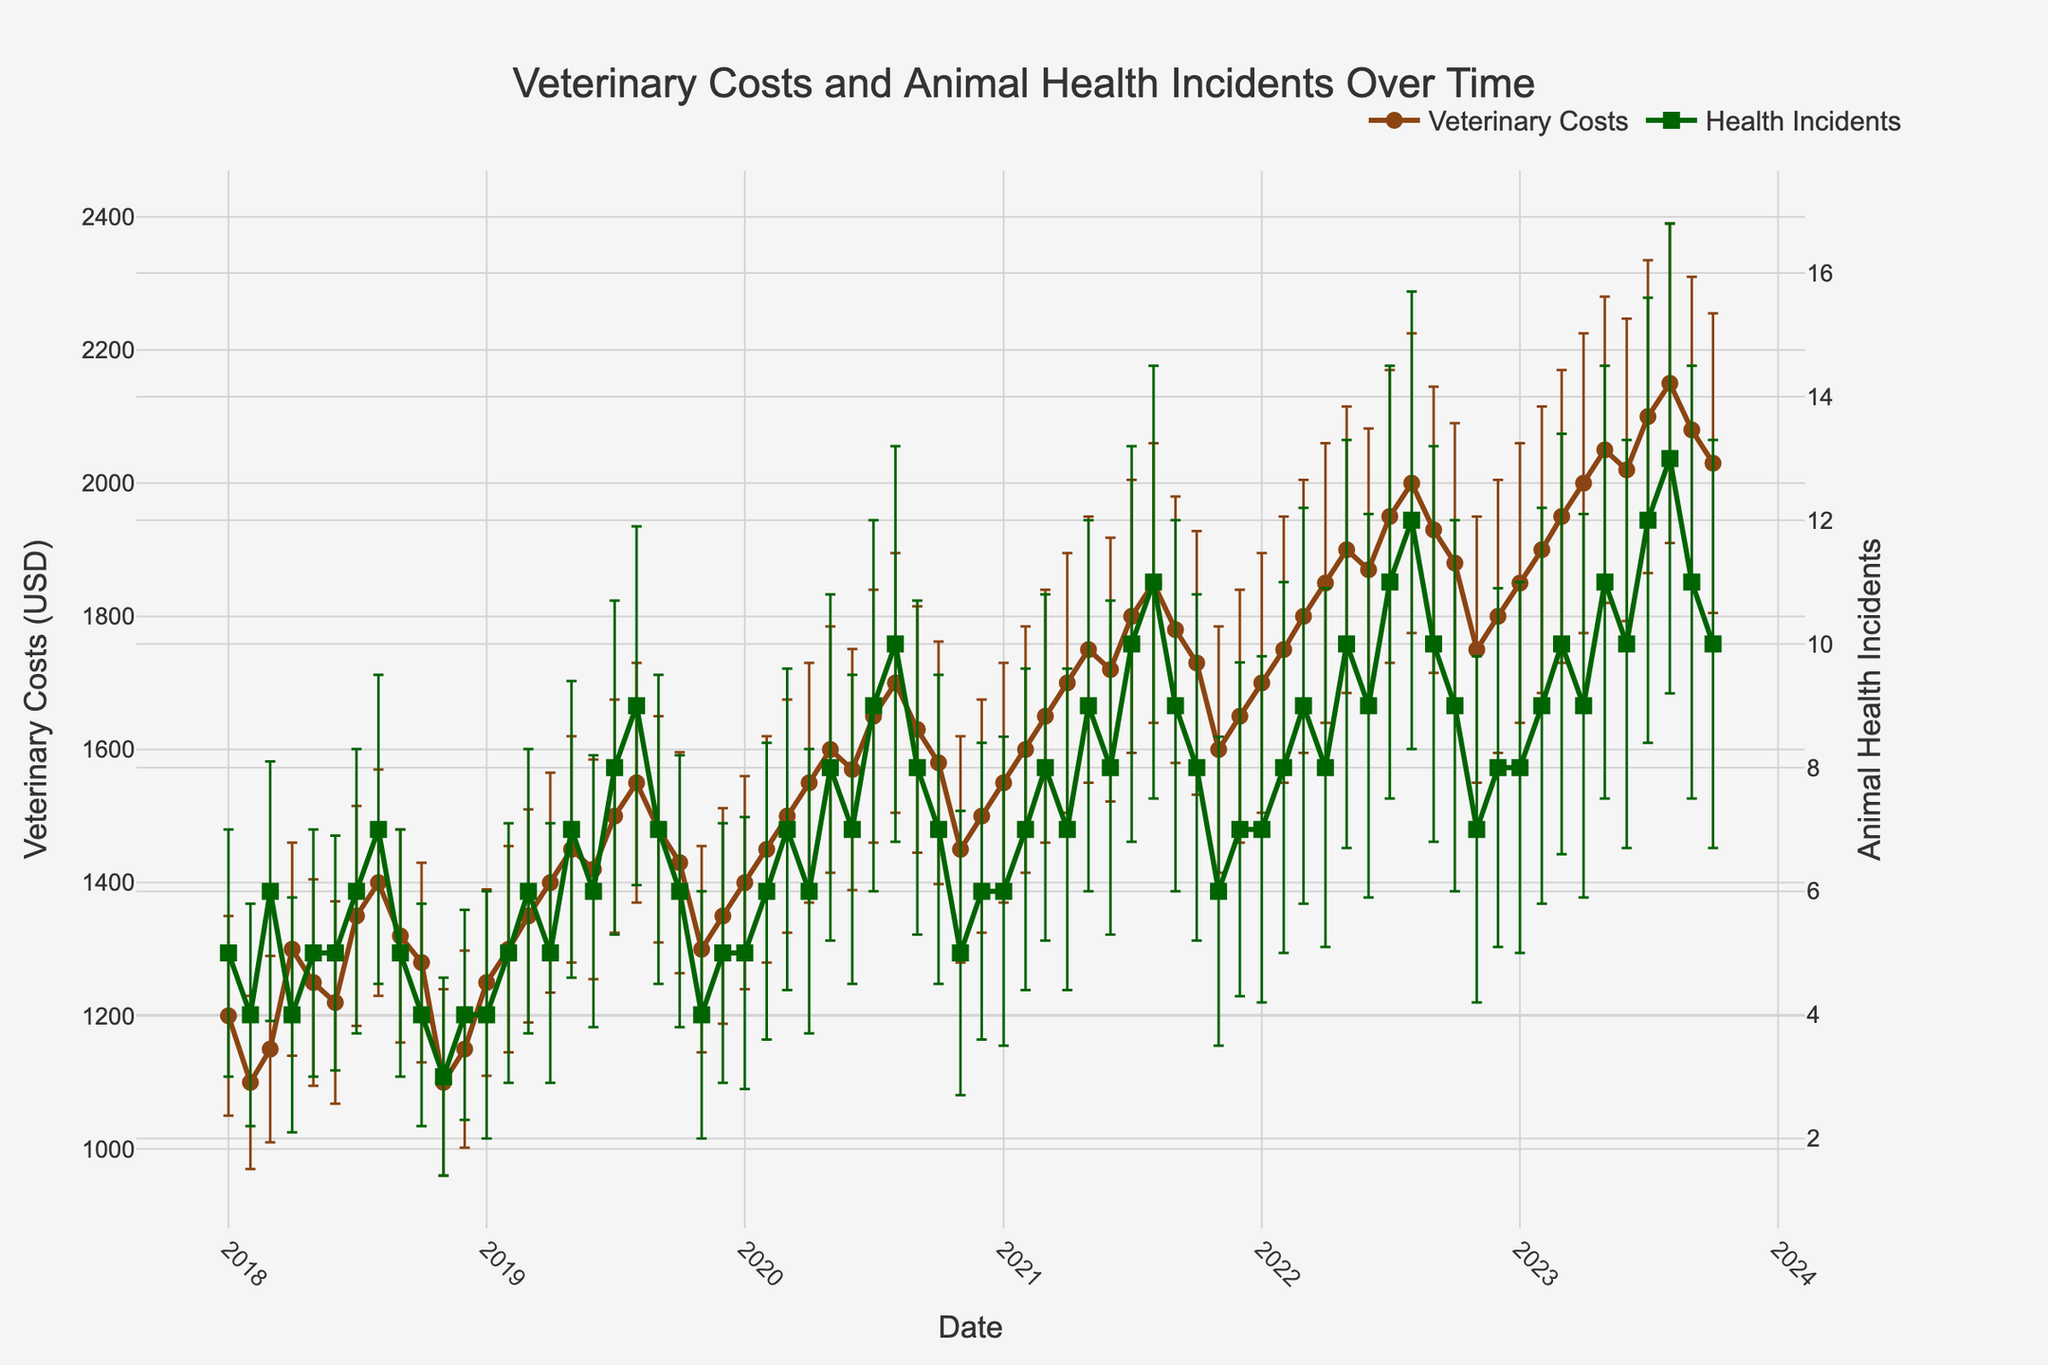What's the title of the figure? The title of the figure is displayed prominently at the top center of the plot.
Answer: Veterinary Costs and Animal Health Incidents Over Time Which data series has more variability, Veterinary Costs or Animal Health Incidents? By observing the size of the error bars, the Animal Health Incidents series has larger error bars throughout the months, indicating more variability.
Answer: Animal Health Incidents During which month and year did the highest cost for veterinary services occur? Observing the y-axis for Veterinary Costs and the corresponding month, the highest veterinary cost occurs around July 2023.
Answer: July 2023 Compare the number of animal health incidents between August 2020 and August 2023. Which month had more incidents? Look at the y-axis for Animal Health Incidents at both August 2020 and August 2023 and compare the numbers. August 2023 had more incidents.
Answer: August 2023 What is the general trend of veterinary costs over the past five years? By observing the line plot for Veterinary Costs, it shows a general upward trend from January 2018 to October 2023.
Answer: Upward trend What can be inferred about the relationship between veterinary costs and animal health incidents over the years? Observing both series together, it is seen that when veterinary costs increase, animal health incidents tend to also increase, suggesting a positive correlation.
Answer: Positive correlation During which month and year were animal health incidents the lowest? Checking the y-axis for Animal Health Incidents and finding the lowest point, it occurs around November 2018.
Answer: November 2018 How do the standard deviations of veterinary costs in January 2018 compare to January 2023? The standard deviation for January 2018 is 150, while for January 2023 it is 210, which is higher.
Answer: January 2023 has a higher standard deviation What is the average number of animal health incidents in June over the entire period? Extract the incident values for each June (5 in 2018, 6 in 2019, 7 in 2020, 8 in 2021, 9 in 2022, and 10 in 2023). Sum these values and divide by the number of years (6). Hence, (5+6+7+8+9+10)/6 = 7.5
Answer: 7.5 Which month and year saw the steepest increase in veterinary costs compared to the previous month? By observing the largest jump in the line plot for Veterinary Costs, the steepest increase occurs between July 2023 and August 2023.
Answer: August 2023 